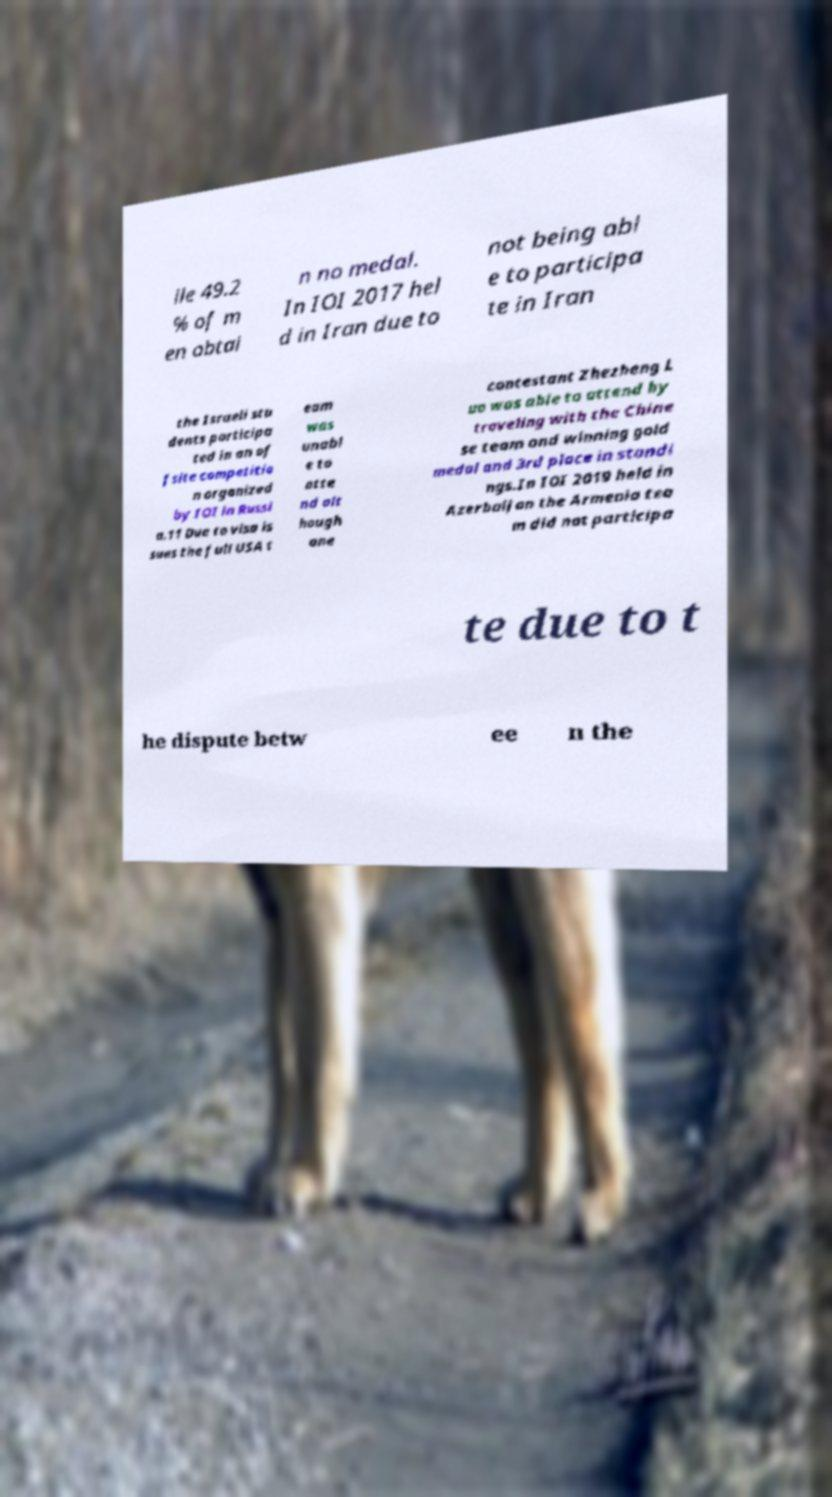Please read and relay the text visible in this image. What does it say? ile 49.2 % of m en obtai n no medal. In IOI 2017 hel d in Iran due to not being abl e to participa te in Iran the Israeli stu dents participa ted in an of fsite competitio n organized by IOI in Russi a.11 Due to visa is sues the full USA t eam was unabl e to atte nd alt hough one contestant Zhezheng L uo was able to attend by traveling with the Chine se team and winning gold medal and 3rd place in standi ngs.In IOI 2019 held in Azerbaijan the Armenia tea m did not participa te due to t he dispute betw ee n the 